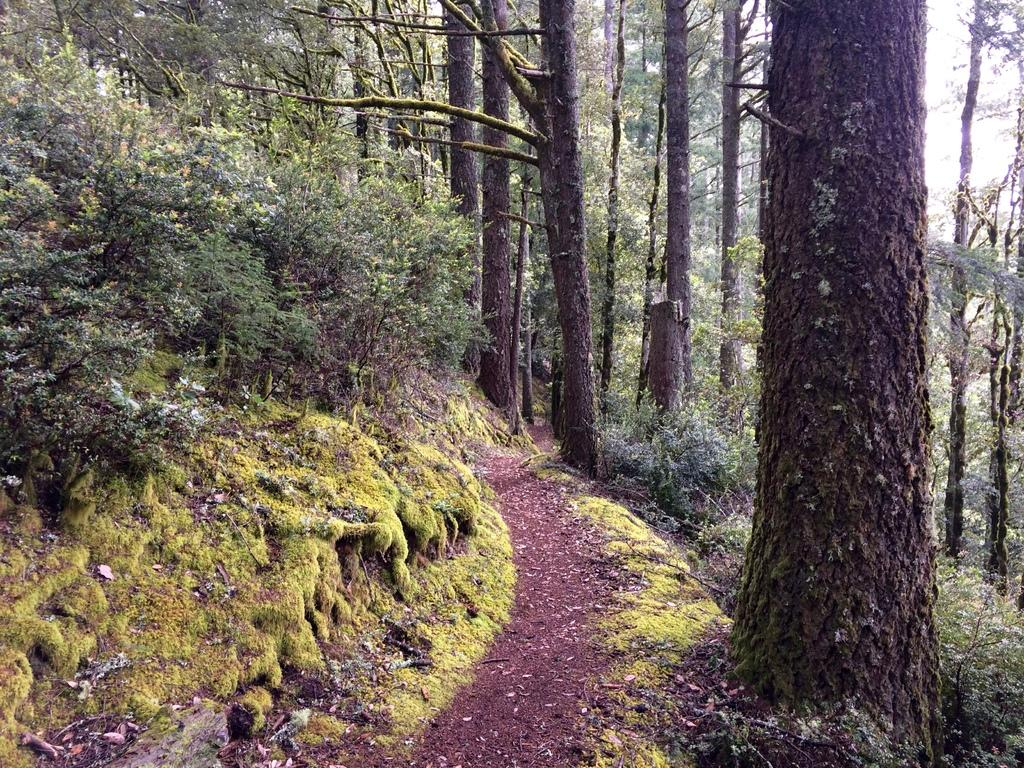What type of vegetation can be seen in the image? There are trees, plants, and grass visible in the image. What is the primary feature that connects the different areas in the image? There is a path in the image. What is visible at the top of the image? The sky is visible in the image. Can you see any goldfish swimming in the image? There are no goldfish present in the image. What type of fuel is being used by the trees in the image? Trees do not use fuel; they produce their own energy through photosynthesis. 